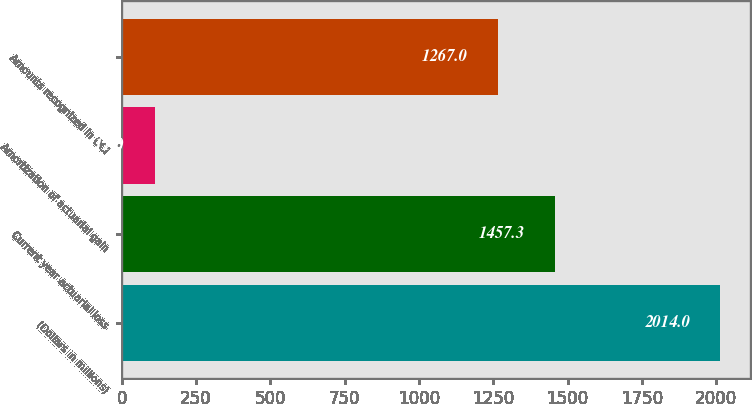<chart> <loc_0><loc_0><loc_500><loc_500><bar_chart><fcel>(Dollars in millions)<fcel>Current year actuarial loss<fcel>Amortization of actuarial gain<fcel>Amounts recognized in OCI<nl><fcel>2014<fcel>1457.3<fcel>111<fcel>1267<nl></chart> 